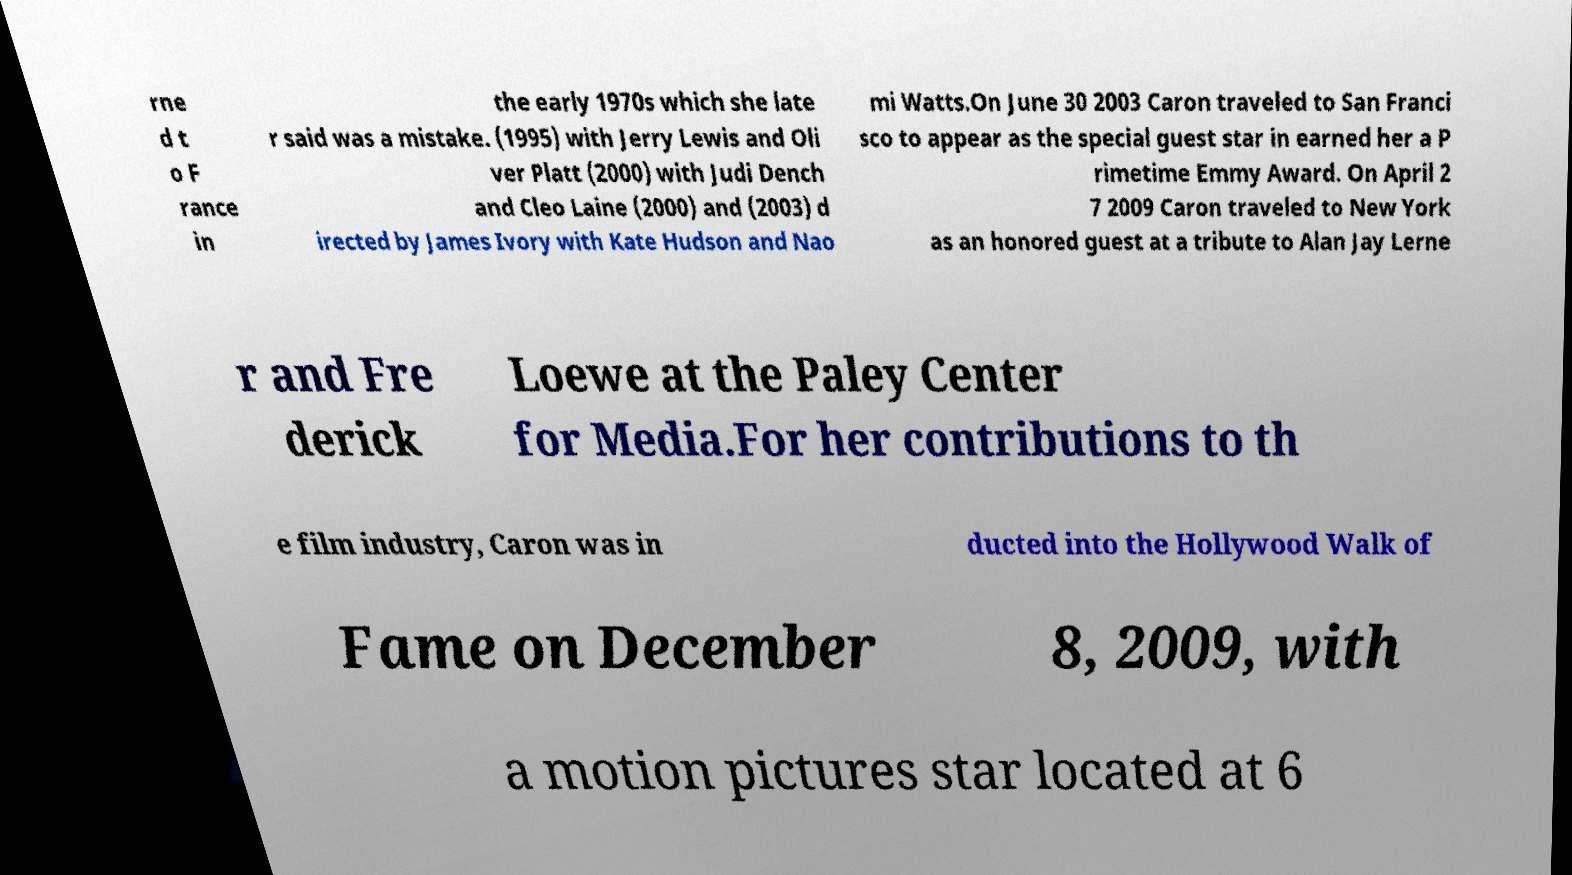Could you extract and type out the text from this image? rne d t o F rance in the early 1970s which she late r said was a mistake. (1995) with Jerry Lewis and Oli ver Platt (2000) with Judi Dench and Cleo Laine (2000) and (2003) d irected by James Ivory with Kate Hudson and Nao mi Watts.On June 30 2003 Caron traveled to San Franci sco to appear as the special guest star in earned her a P rimetime Emmy Award. On April 2 7 2009 Caron traveled to New York as an honored guest at a tribute to Alan Jay Lerne r and Fre derick Loewe at the Paley Center for Media.For her contributions to th e film industry, Caron was in ducted into the Hollywood Walk of Fame on December 8, 2009, with a motion pictures star located at 6 